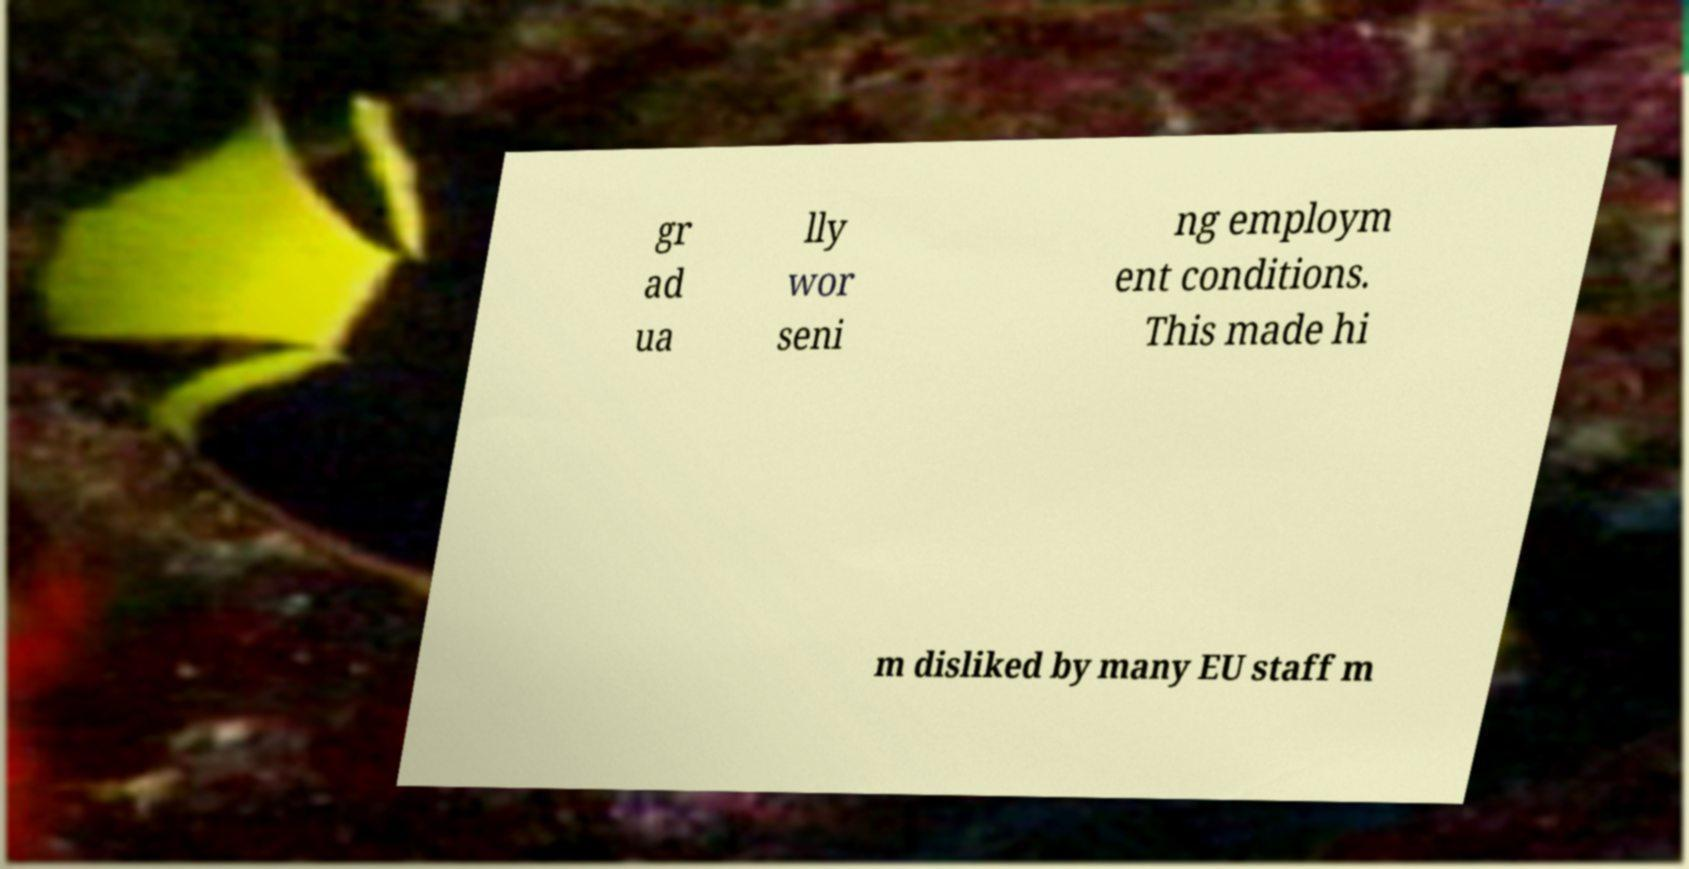Can you read and provide the text displayed in the image?This photo seems to have some interesting text. Can you extract and type it out for me? gr ad ua lly wor seni ng employm ent conditions. This made hi m disliked by many EU staff m 